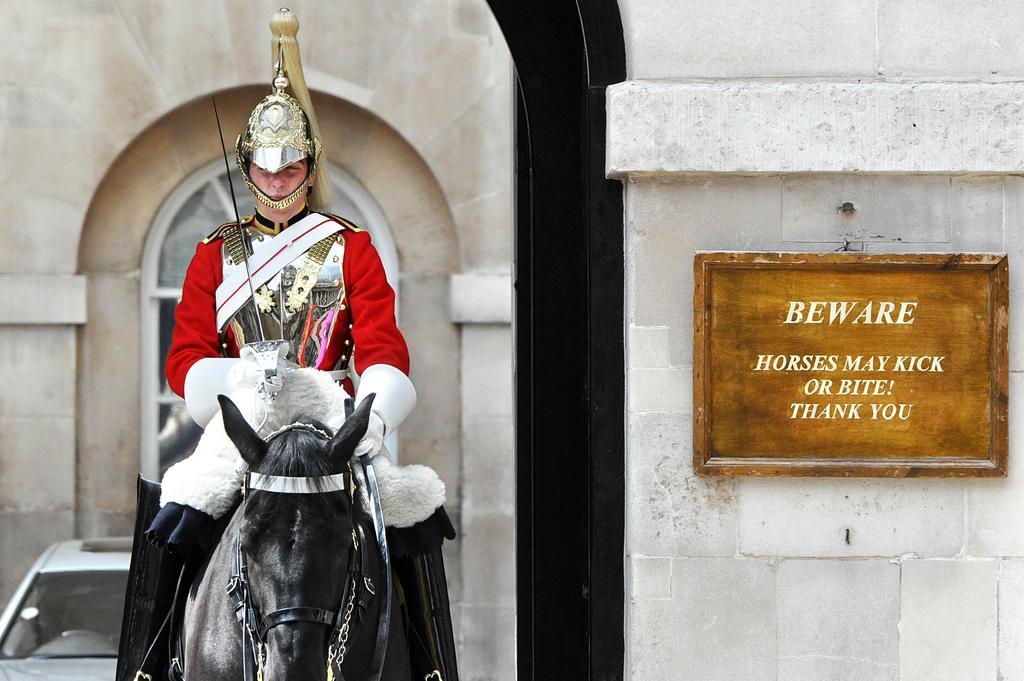What is the main object in the image? There is a name board in the image. What activity is the person in the image engaged in? The person is sitting on a horse in the image. What vehicle is visible behind the person on the horse? There is a car behind the person on the horse. What can be seen in the background of the image? There is a wall in the background of the image. How many ants can be seen crawling on the name board in the image? There are no ants visible on the name board in the image. What type of account does the person on the horse have with the car owner? There is no information about any accounts or interactions between the person on the horse and the car owner in the image. 